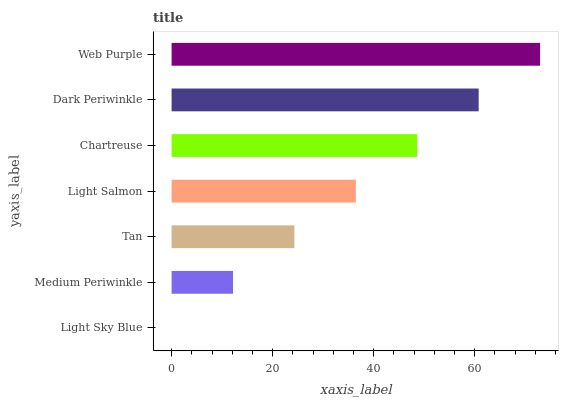Is Light Sky Blue the minimum?
Answer yes or no. Yes. Is Web Purple the maximum?
Answer yes or no. Yes. Is Medium Periwinkle the minimum?
Answer yes or no. No. Is Medium Periwinkle the maximum?
Answer yes or no. No. Is Medium Periwinkle greater than Light Sky Blue?
Answer yes or no. Yes. Is Light Sky Blue less than Medium Periwinkle?
Answer yes or no. Yes. Is Light Sky Blue greater than Medium Periwinkle?
Answer yes or no. No. Is Medium Periwinkle less than Light Sky Blue?
Answer yes or no. No. Is Light Salmon the high median?
Answer yes or no. Yes. Is Light Salmon the low median?
Answer yes or no. Yes. Is Medium Periwinkle the high median?
Answer yes or no. No. Is Web Purple the low median?
Answer yes or no. No. 